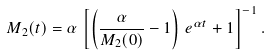<formula> <loc_0><loc_0><loc_500><loc_500>M _ { 2 } ( t ) = \alpha \, \left [ \left ( \frac { \alpha } { M _ { 2 } ( 0 ) } - 1 \right ) \, e ^ { \alpha t } + 1 \right ] ^ { - 1 } .</formula> 